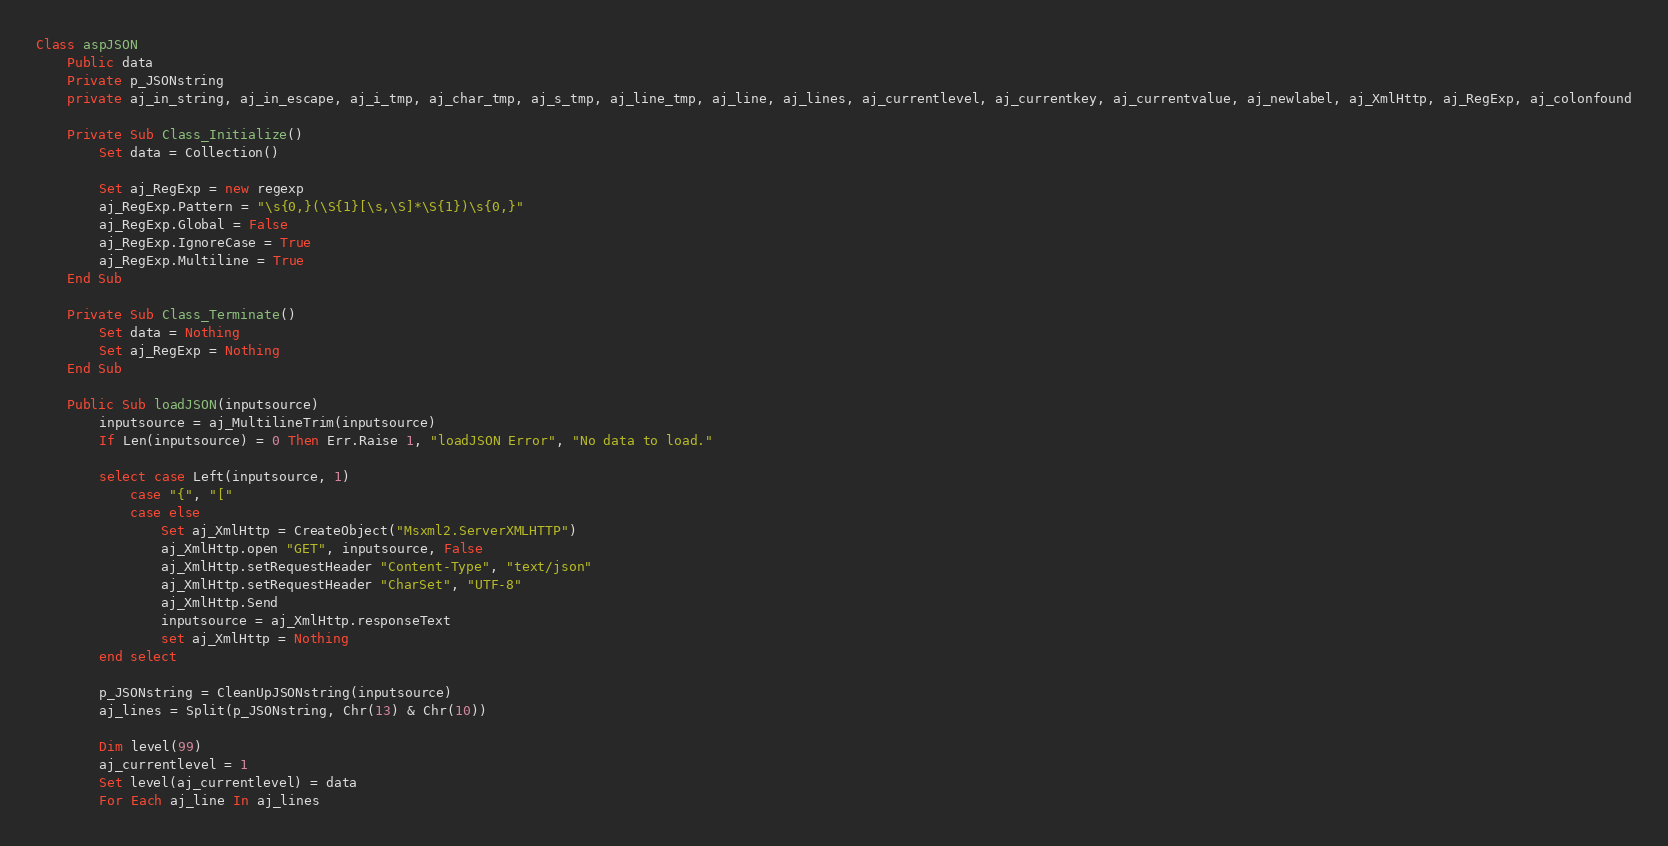Convert code to text. <code><loc_0><loc_0><loc_500><loc_500><_VisualBasic_>Class aspJSON
	Public data
	Private p_JSONstring
	private aj_in_string, aj_in_escape, aj_i_tmp, aj_char_tmp, aj_s_tmp, aj_line_tmp, aj_line, aj_lines, aj_currentlevel, aj_currentkey, aj_currentvalue, aj_newlabel, aj_XmlHttp, aj_RegExp, aj_colonfound

	Private Sub Class_Initialize()
		Set data = Collection()

	    Set aj_RegExp = new regexp
	    aj_RegExp.Pattern = "\s{0,}(\S{1}[\s,\S]*\S{1})\s{0,}"
	    aj_RegExp.Global = False
	    aj_RegExp.IgnoreCase = True
	    aj_RegExp.Multiline = True
	End Sub

	Private Sub Class_Terminate()
		Set data = Nothing
	    Set aj_RegExp = Nothing
	End Sub

	Public Sub loadJSON(inputsource)
		inputsource = aj_MultilineTrim(inputsource)
		If Len(inputsource) = 0 Then Err.Raise 1, "loadJSON Error", "No data to load."
		
		select case Left(inputsource, 1)
			case "{", "["
			case else
				Set aj_XmlHttp = CreateObject("Msxml2.ServerXMLHTTP")
				aj_XmlHttp.open "GET", inputsource, False
				aj_XmlHttp.setRequestHeader "Content-Type", "text/json"
				aj_XmlHttp.setRequestHeader "CharSet", "UTF-8"
				aj_XmlHttp.Send
				inputsource = aj_XmlHttp.responseText
				set aj_XmlHttp = Nothing
		end select

		p_JSONstring = CleanUpJSONstring(inputsource)		
		aj_lines = Split(p_JSONstring, Chr(13) & Chr(10))

		Dim level(99)
		aj_currentlevel = 1
		Set level(aj_currentlevel) = data
		For Each aj_line In aj_lines</code> 